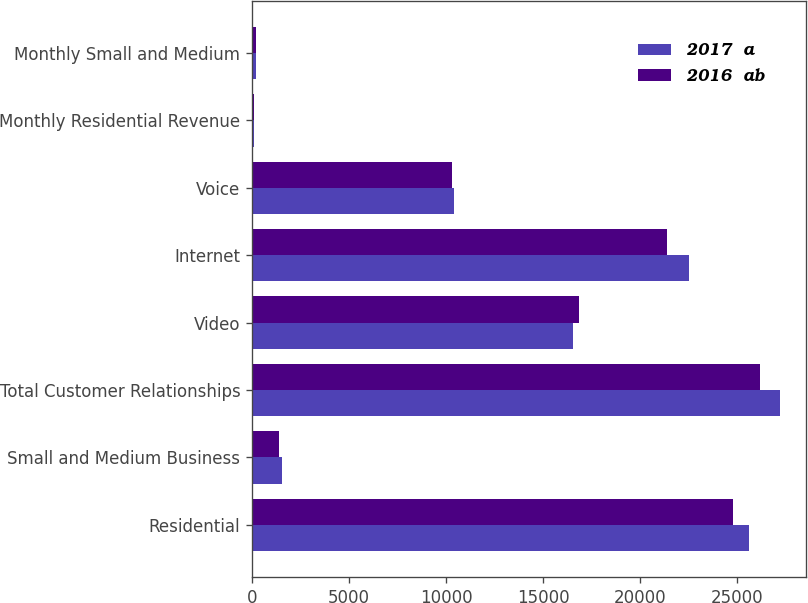Convert chart to OTSL. <chart><loc_0><loc_0><loc_500><loc_500><stacked_bar_chart><ecel><fcel>Residential<fcel>Small and Medium Business<fcel>Total Customer Relationships<fcel>Video<fcel>Internet<fcel>Voice<fcel>Monthly Residential Revenue<fcel>Monthly Small and Medium<nl><fcel>2017  a<fcel>25639<fcel>1560<fcel>27199<fcel>16544<fcel>22545<fcel>10427<fcel>109.75<fcel>207.36<nl><fcel>2016  ab<fcel>24801<fcel>1404<fcel>26205<fcel>16836<fcel>21374<fcel>10327<fcel>109.57<fcel>213.87<nl></chart> 